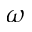Convert formula to latex. <formula><loc_0><loc_0><loc_500><loc_500>\omega</formula> 